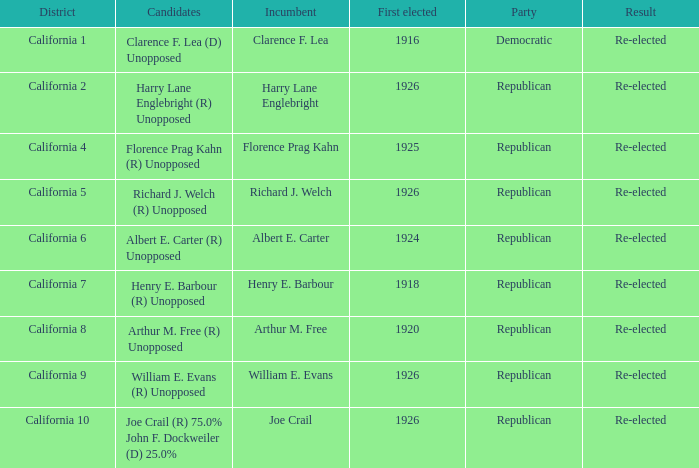 how many candidates with district being california 7 1.0. 